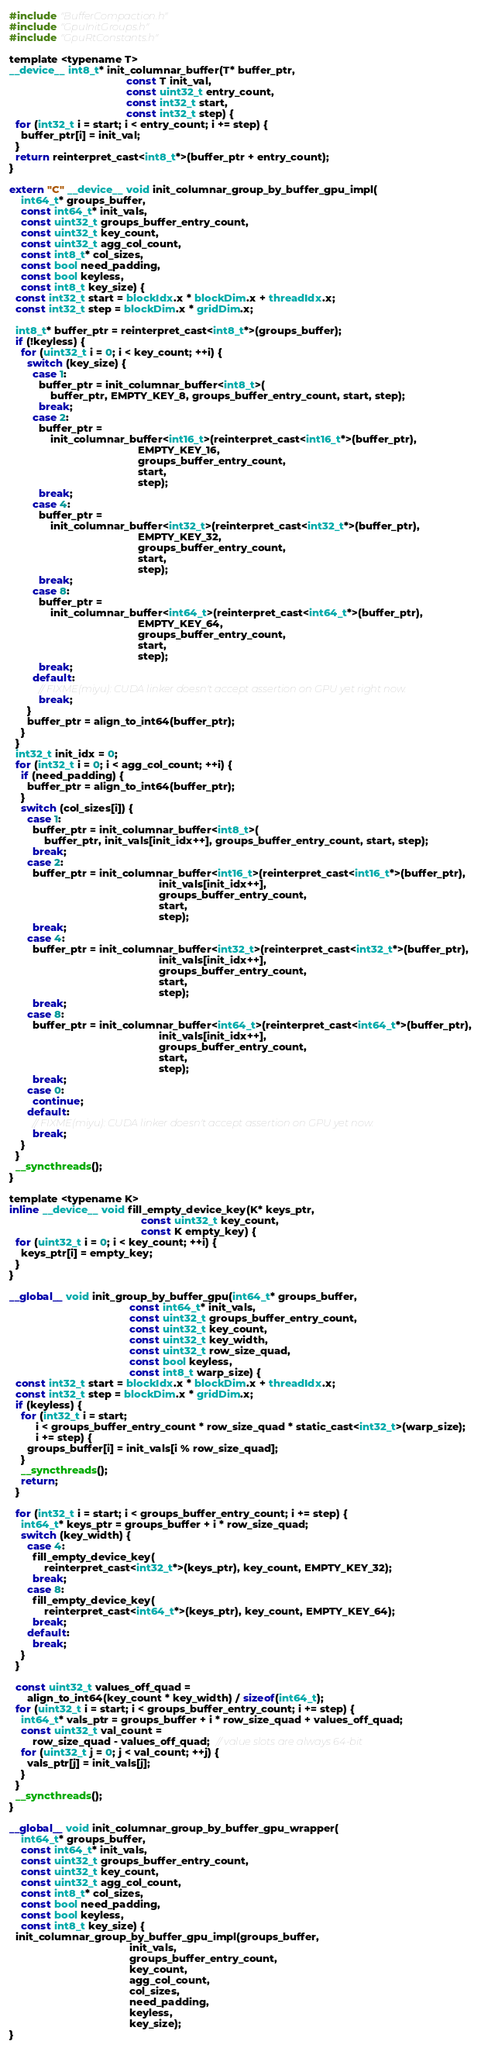<code> <loc_0><loc_0><loc_500><loc_500><_Cuda_>#include "BufferCompaction.h"
#include "GpuInitGroups.h"
#include "GpuRtConstants.h"

template <typename T>
__device__ int8_t* init_columnar_buffer(T* buffer_ptr,
                                        const T init_val,
                                        const uint32_t entry_count,
                                        const int32_t start,
                                        const int32_t step) {
  for (int32_t i = start; i < entry_count; i += step) {
    buffer_ptr[i] = init_val;
  }
  return reinterpret_cast<int8_t*>(buffer_ptr + entry_count);
}

extern "C" __device__ void init_columnar_group_by_buffer_gpu_impl(
    int64_t* groups_buffer,
    const int64_t* init_vals,
    const uint32_t groups_buffer_entry_count,
    const uint32_t key_count,
    const uint32_t agg_col_count,
    const int8_t* col_sizes,
    const bool need_padding,
    const bool keyless,
    const int8_t key_size) {
  const int32_t start = blockIdx.x * blockDim.x + threadIdx.x;
  const int32_t step = blockDim.x * gridDim.x;

  int8_t* buffer_ptr = reinterpret_cast<int8_t*>(groups_buffer);
  if (!keyless) {
    for (uint32_t i = 0; i < key_count; ++i) {
      switch (key_size) {
        case 1:
          buffer_ptr = init_columnar_buffer<int8_t>(
              buffer_ptr, EMPTY_KEY_8, groups_buffer_entry_count, start, step);
          break;
        case 2:
          buffer_ptr =
              init_columnar_buffer<int16_t>(reinterpret_cast<int16_t*>(buffer_ptr),
                                            EMPTY_KEY_16,
                                            groups_buffer_entry_count,
                                            start,
                                            step);
          break;
        case 4:
          buffer_ptr =
              init_columnar_buffer<int32_t>(reinterpret_cast<int32_t*>(buffer_ptr),
                                            EMPTY_KEY_32,
                                            groups_buffer_entry_count,
                                            start,
                                            step);
          break;
        case 8:
          buffer_ptr =
              init_columnar_buffer<int64_t>(reinterpret_cast<int64_t*>(buffer_ptr),
                                            EMPTY_KEY_64,
                                            groups_buffer_entry_count,
                                            start,
                                            step);
          break;
        default:
          // FIXME(miyu): CUDA linker doesn't accept assertion on GPU yet right now.
          break;
      }
      buffer_ptr = align_to_int64(buffer_ptr);
    }
  }
  int32_t init_idx = 0;
  for (int32_t i = 0; i < agg_col_count; ++i) {
    if (need_padding) {
      buffer_ptr = align_to_int64(buffer_ptr);
    }
    switch (col_sizes[i]) {
      case 1:
        buffer_ptr = init_columnar_buffer<int8_t>(
            buffer_ptr, init_vals[init_idx++], groups_buffer_entry_count, start, step);
        break;
      case 2:
        buffer_ptr = init_columnar_buffer<int16_t>(reinterpret_cast<int16_t*>(buffer_ptr),
                                                   init_vals[init_idx++],
                                                   groups_buffer_entry_count,
                                                   start,
                                                   step);
        break;
      case 4:
        buffer_ptr = init_columnar_buffer<int32_t>(reinterpret_cast<int32_t*>(buffer_ptr),
                                                   init_vals[init_idx++],
                                                   groups_buffer_entry_count,
                                                   start,
                                                   step);
        break;
      case 8:
        buffer_ptr = init_columnar_buffer<int64_t>(reinterpret_cast<int64_t*>(buffer_ptr),
                                                   init_vals[init_idx++],
                                                   groups_buffer_entry_count,
                                                   start,
                                                   step);
        break;
      case 0:
        continue;
      default:
        // FIXME(miyu): CUDA linker doesn't accept assertion on GPU yet now.
        break;
    }
  }
  __syncthreads();
}

template <typename K>
inline __device__ void fill_empty_device_key(K* keys_ptr,
                                             const uint32_t key_count,
                                             const K empty_key) {
  for (uint32_t i = 0; i < key_count; ++i) {
    keys_ptr[i] = empty_key;
  }
}

__global__ void init_group_by_buffer_gpu(int64_t* groups_buffer,
                                         const int64_t* init_vals,
                                         const uint32_t groups_buffer_entry_count,
                                         const uint32_t key_count,
                                         const uint32_t key_width,
                                         const uint32_t row_size_quad,
                                         const bool keyless,
                                         const int8_t warp_size) {
  const int32_t start = blockIdx.x * blockDim.x + threadIdx.x;
  const int32_t step = blockDim.x * gridDim.x;
  if (keyless) {
    for (int32_t i = start;
         i < groups_buffer_entry_count * row_size_quad * static_cast<int32_t>(warp_size);
         i += step) {
      groups_buffer[i] = init_vals[i % row_size_quad];
    }
    __syncthreads();
    return;
  }

  for (int32_t i = start; i < groups_buffer_entry_count; i += step) {
    int64_t* keys_ptr = groups_buffer + i * row_size_quad;
    switch (key_width) {
      case 4:
        fill_empty_device_key(
            reinterpret_cast<int32_t*>(keys_ptr), key_count, EMPTY_KEY_32);
        break;
      case 8:
        fill_empty_device_key(
            reinterpret_cast<int64_t*>(keys_ptr), key_count, EMPTY_KEY_64);
        break;
      default:
        break;
    }
  }

  const uint32_t values_off_quad =
      align_to_int64(key_count * key_width) / sizeof(int64_t);
  for (uint32_t i = start; i < groups_buffer_entry_count; i += step) {
    int64_t* vals_ptr = groups_buffer + i * row_size_quad + values_off_quad;
    const uint32_t val_count =
        row_size_quad - values_off_quad;  // value slots are always 64-bit
    for (uint32_t j = 0; j < val_count; ++j) {
      vals_ptr[j] = init_vals[j];
    }
  }
  __syncthreads();
}

__global__ void init_columnar_group_by_buffer_gpu_wrapper(
    int64_t* groups_buffer,
    const int64_t* init_vals,
    const uint32_t groups_buffer_entry_count,
    const uint32_t key_count,
    const uint32_t agg_col_count,
    const int8_t* col_sizes,
    const bool need_padding,
    const bool keyless,
    const int8_t key_size) {
  init_columnar_group_by_buffer_gpu_impl(groups_buffer,
                                         init_vals,
                                         groups_buffer_entry_count,
                                         key_count,
                                         agg_col_count,
                                         col_sizes,
                                         need_padding,
                                         keyless,
                                         key_size);
}
</code> 